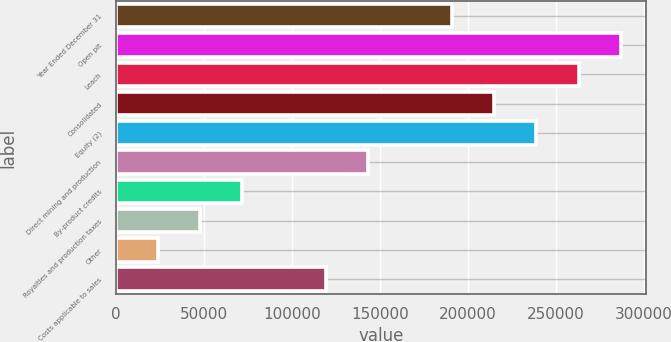<chart> <loc_0><loc_0><loc_500><loc_500><bar_chart><fcel>Year Ended December 31<fcel>Open pit<fcel>Leach<fcel>Consolidated<fcel>Equity (2)<fcel>Direct mining and production<fcel>By-product credits<fcel>Royalties and production taxes<fcel>Other<fcel>Costs applicable to sales<nl><fcel>191282<fcel>286922<fcel>263012<fcel>215192<fcel>239102<fcel>143462<fcel>71732.7<fcel>47822.8<fcel>23912.9<fcel>119552<nl></chart> 